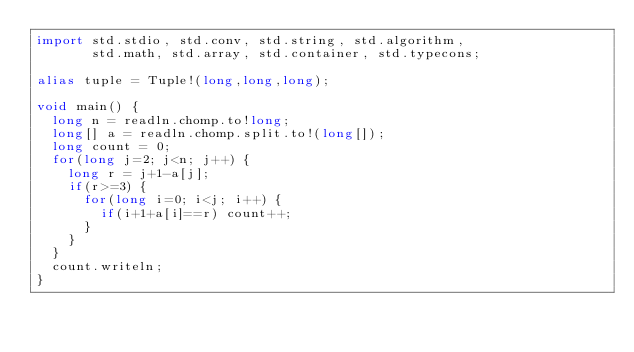Convert code to text. <code><loc_0><loc_0><loc_500><loc_500><_D_>import std.stdio, std.conv, std.string, std.algorithm,
       std.math, std.array, std.container, std.typecons;

alias tuple = Tuple!(long,long,long);

void main() {
  long n = readln.chomp.to!long;
  long[] a = readln.chomp.split.to!(long[]);
  long count = 0;
  for(long j=2; j<n; j++) {
    long r = j+1-a[j];
    if(r>=3) {
      for(long i=0; i<j; i++) {
        if(i+1+a[i]==r) count++;
      }
    }
  }
  count.writeln;
}
</code> 